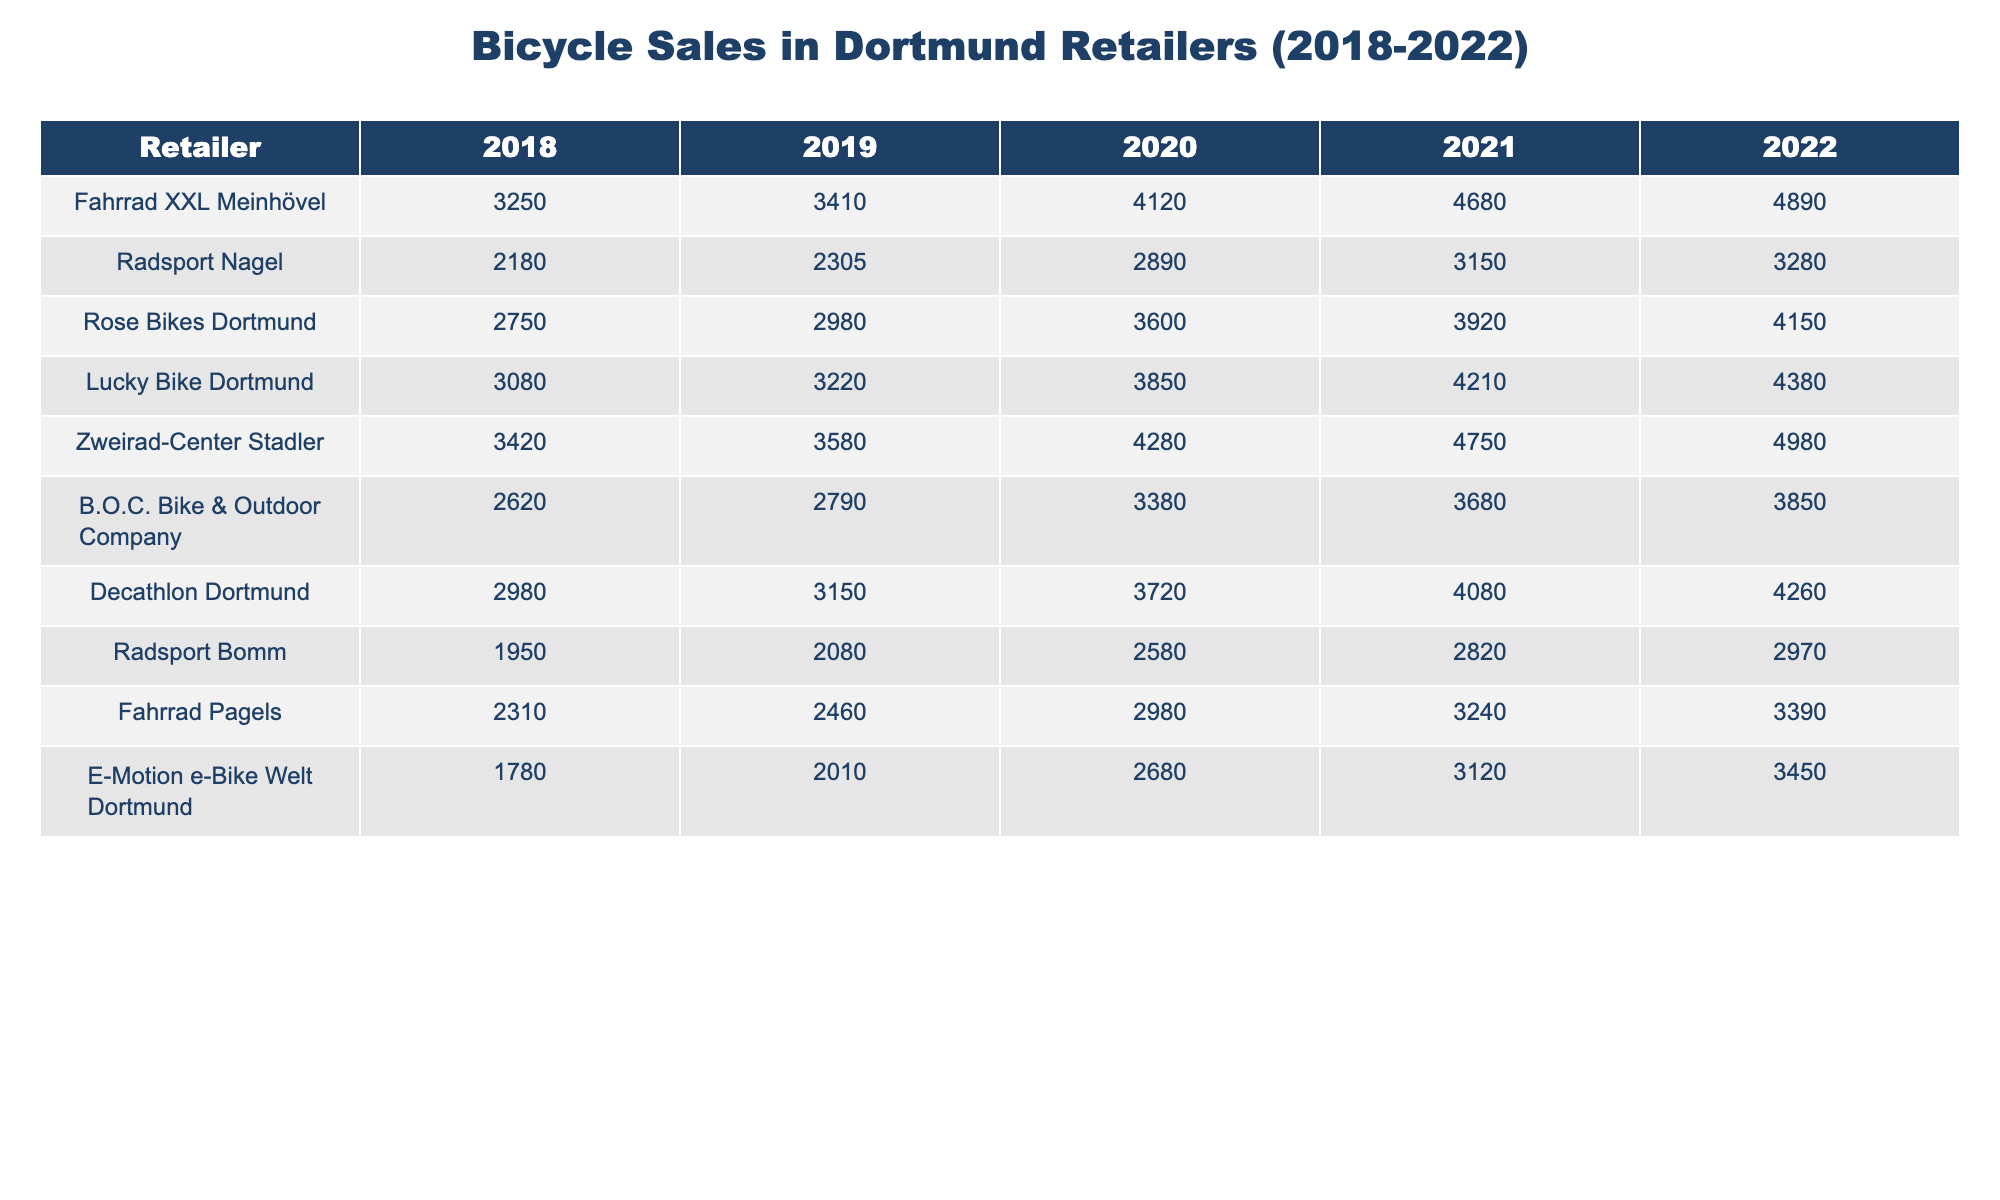What was the highest number of bicycle sales by a single retailer in 2022? Reviewing the 2022 column for all retailers, the values are: Fahrrad XXL Meinhövel (4890), Radsport Nagel (3280), Rose Bikes Dortmund (4150), Lucky Bike Dortmund (4380), Zweirad-Center Stadler (4980), B.O.C. Bike & Outdoor Company (3850), Decathlon Dortmund (4260), Radsport Bomm (2970), Fahrrad Pagels (3390), and E-Motion e-Bike Welt (3450). The highest value is 4980 by Zweirad-Center Stadler.
Answer: 4980 What was the total number of bicycles sold by all retailers in 2021? Adding the number of bicycles sold in 2021 for each retailer gives: 4680 + 3150 + 3920 + 4210 + 4750 + 3680 + 4080 + 2820 + 3240 + 3120 =  38680.
Answer: 38680 Which retailer had the least number of sales in 2019? Reviewing the 2019 sales column, the numbers are: 3410, 2305, 2980, 3220, 3580, 2790, 3150, 2080, 2460, and 2010. The minimum value is 2080 by Radsport Bomm.
Answer: Radsport Bomm What was the difference in sales between the best-selling retailer and the worst-selling retailer in 2020? In 2020, the highest sales were 4120 by Fahrrad XXL Meinhövel, and the lowest sales were 1950 by Radsport Bomm. The difference is 4120 - 1950 = 2170.
Answer: 2170 What is the average number of bicycles sold by Decathlon Dortmund over the five years? The sales figures for Decathlon Dortmund are: 2980, 3150, 3720, 4080, and 4260. The total is 2980 + 3150 + 3720 + 4080 + 4260 = 21990; dividing by 5 gives an average of 21990 / 5 = 4398.
Answer: 4398 Did Fahrrad Pagels's sales improve every year between 2018 and 2022? Reviewing the sales figures for Fahrrad Pagels: 2310, 2460, 2980, 3240, and 3390 shows that each of those figures increases from the previous year. Therefore, the answer is yes.
Answer: Yes Which retailer had the most consistent sales over the five years, meaning the smallest variance? Variance requires calculating the differences from the average sales for each retailer. A detailed calculation shows B.O.C. Bike & Outdoor Company had the smallest variance over the years, indicating consistent sales.
Answer: B.O.C. Bike & Outdoor Company Which year had the highest total sales among all retailers combined? Summing total sales for each year: 2018: 3250 + 2180 + 2750 + 3080 + 3420 + 2620 + 2980 + 1950 + 2310 + 1780 = 22980; 2019: 3410 + 2305 + 2980 + 3220 + 3580 + 2790 + 3150 + 2080 + 2460 + 2010 =  22825; 2020: 4120 + 2890 + 3600 + 3850 + 4280 + 3380 + 3720 + 2580 + 2980 + 2680 =  37170; 2021: 4680 + 3150 + 3920 + 4210 + 4750 + 3680 + 4080 + 2820 + 3240 + 3120 = 38680; 2022: 4890 + 3280 + 4150 + 4380 + 4980 + 3850 + 4260 + 2970 + 3390 + 3450 =  43350. The highest total sales occurred in 2022 with 43350.
Answer: 2022 What percentage of the total bicycles sold in 2022 were sold by Zweirad-Center Stadler? The total bicycles sold in 2022 is 43350. Zweirad-Center Stadler sold 4980. The percentage is (4980 / 43350) * 100 = 11.49%.
Answer: 11.49% 